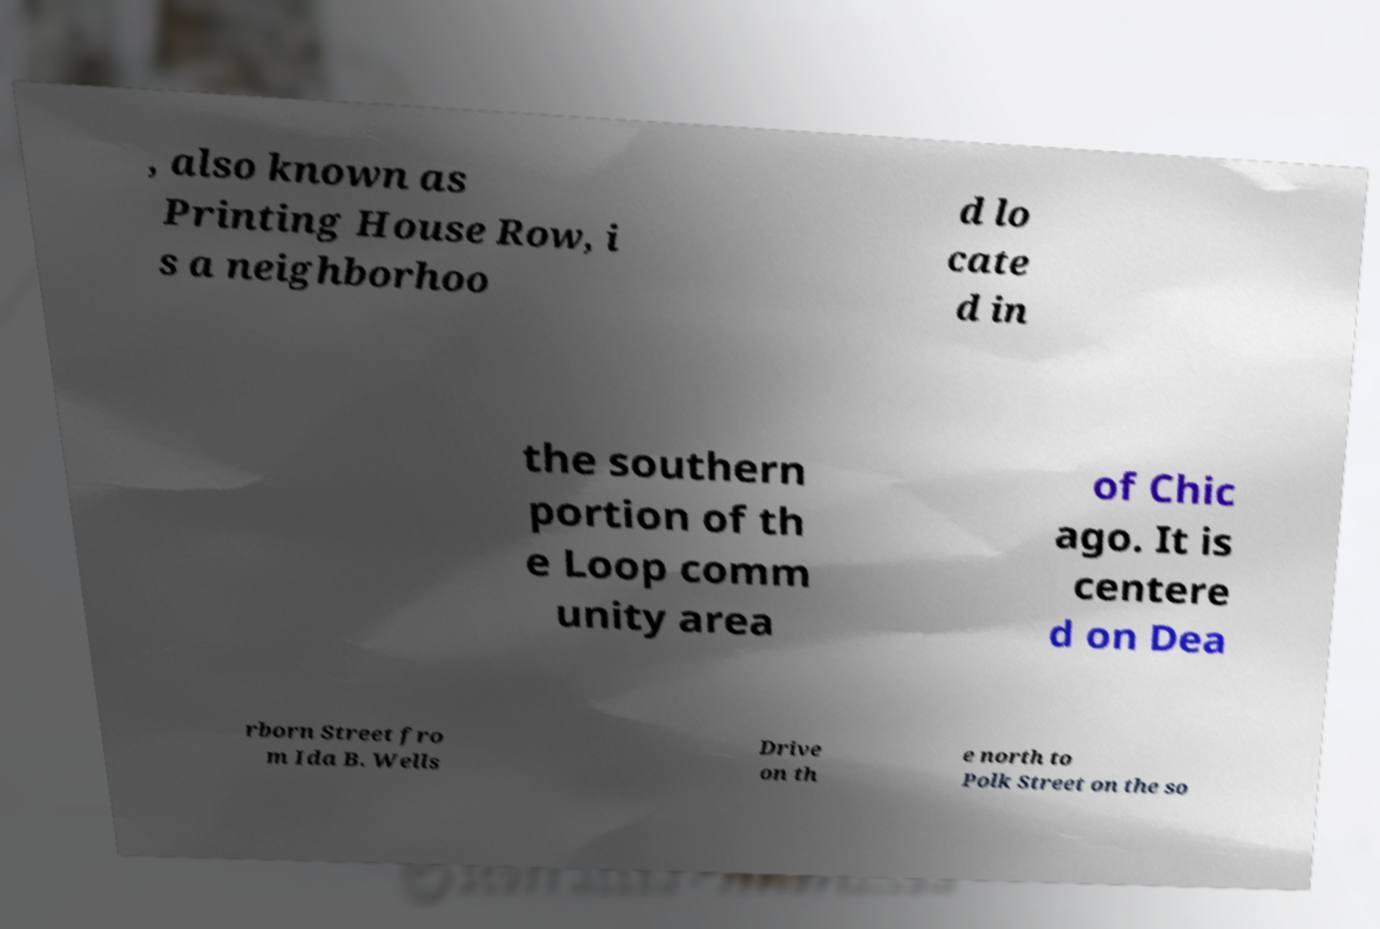Could you assist in decoding the text presented in this image and type it out clearly? , also known as Printing House Row, i s a neighborhoo d lo cate d in the southern portion of th e Loop comm unity area of Chic ago. It is centere d on Dea rborn Street fro m Ida B. Wells Drive on th e north to Polk Street on the so 